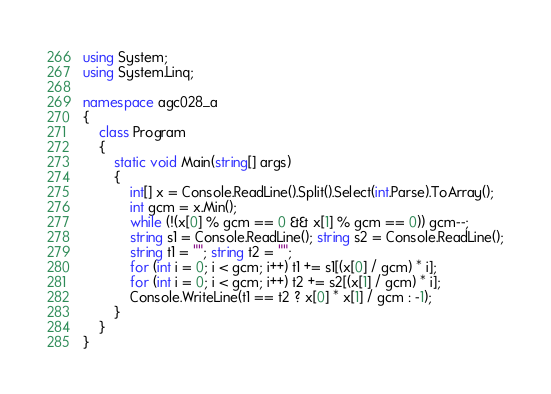<code> <loc_0><loc_0><loc_500><loc_500><_C#_>using System;
using System.Linq;

namespace agc028_a
{
	class Program
	{
		static void Main(string[] args)
		{
			int[] x = Console.ReadLine().Split().Select(int.Parse).ToArray();
			int gcm = x.Min();
			while (!(x[0] % gcm == 0 && x[1] % gcm == 0)) gcm--;
			string s1 = Console.ReadLine(); string s2 = Console.ReadLine();
			string t1 = ""; string t2 = "";
			for (int i = 0; i < gcm; i++) t1 += s1[(x[0] / gcm) * i];
			for (int i = 0; i < gcm; i++) t2 += s2[(x[1] / gcm) * i];
			Console.WriteLine(t1 == t2 ? x[0] * x[1] / gcm : -1);
		}
	}
}</code> 